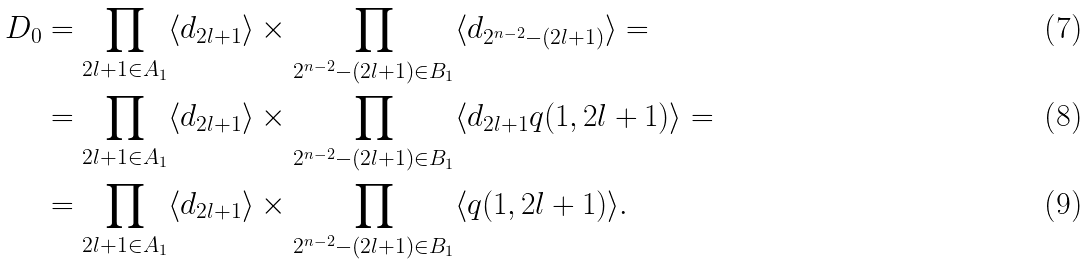Convert formula to latex. <formula><loc_0><loc_0><loc_500><loc_500>D _ { 0 } & = \prod _ { 2 l + 1 \in A _ { 1 } } \langle d _ { 2 l + 1 } \rangle \times \prod _ { 2 ^ { n - 2 } - ( 2 l + 1 ) \in B _ { 1 } } \langle d _ { 2 ^ { n - 2 } - ( 2 l + 1 ) } \rangle = \\ & = \prod _ { 2 l + 1 \in A _ { 1 } } \langle d _ { 2 l + 1 } \rangle \times \prod _ { 2 ^ { n - 2 } - ( 2 l + 1 ) \in B _ { 1 } } \langle d _ { 2 l + 1 } q ( 1 , 2 l + 1 ) \rangle = \\ & = \prod _ { 2 l + 1 \in A _ { 1 } } \langle d _ { 2 l + 1 } \rangle \times \prod _ { 2 ^ { n - 2 } - ( 2 l + 1 ) \in B _ { 1 } } \langle q ( 1 , 2 l + 1 ) \rangle .</formula> 